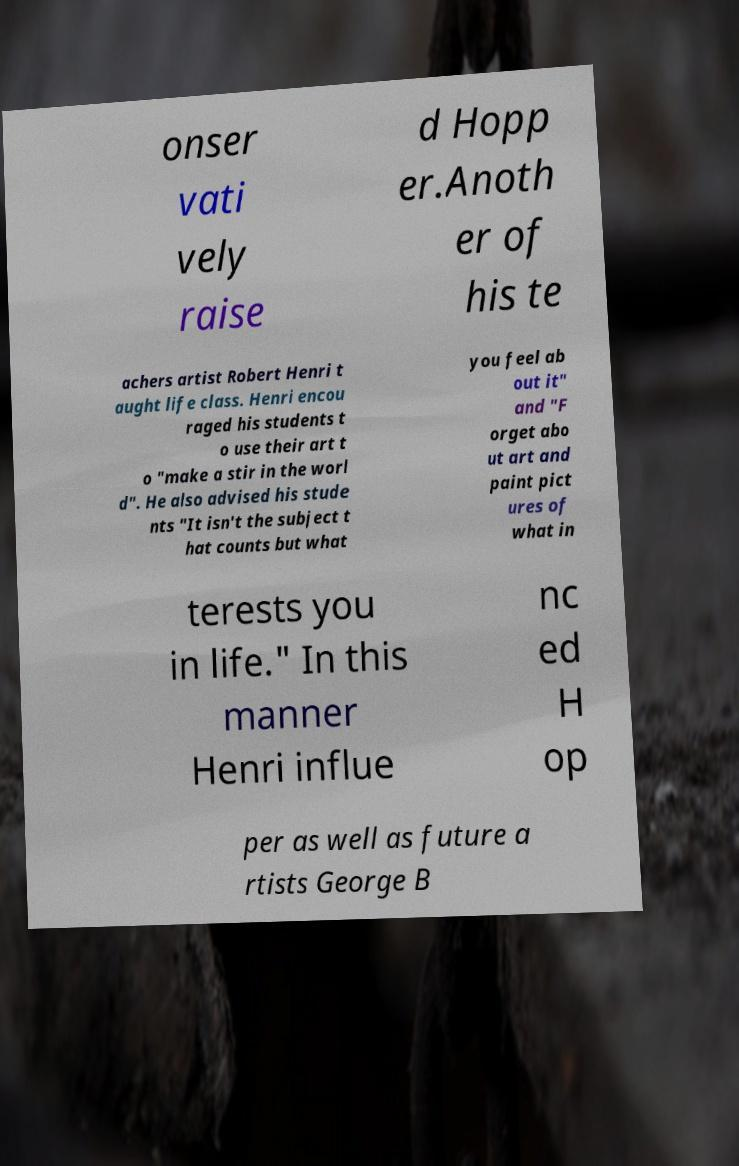I need the written content from this picture converted into text. Can you do that? onser vati vely raise d Hopp er.Anoth er of his te achers artist Robert Henri t aught life class. Henri encou raged his students t o use their art t o "make a stir in the worl d". He also advised his stude nts "It isn't the subject t hat counts but what you feel ab out it" and "F orget abo ut art and paint pict ures of what in terests you in life." In this manner Henri influe nc ed H op per as well as future a rtists George B 